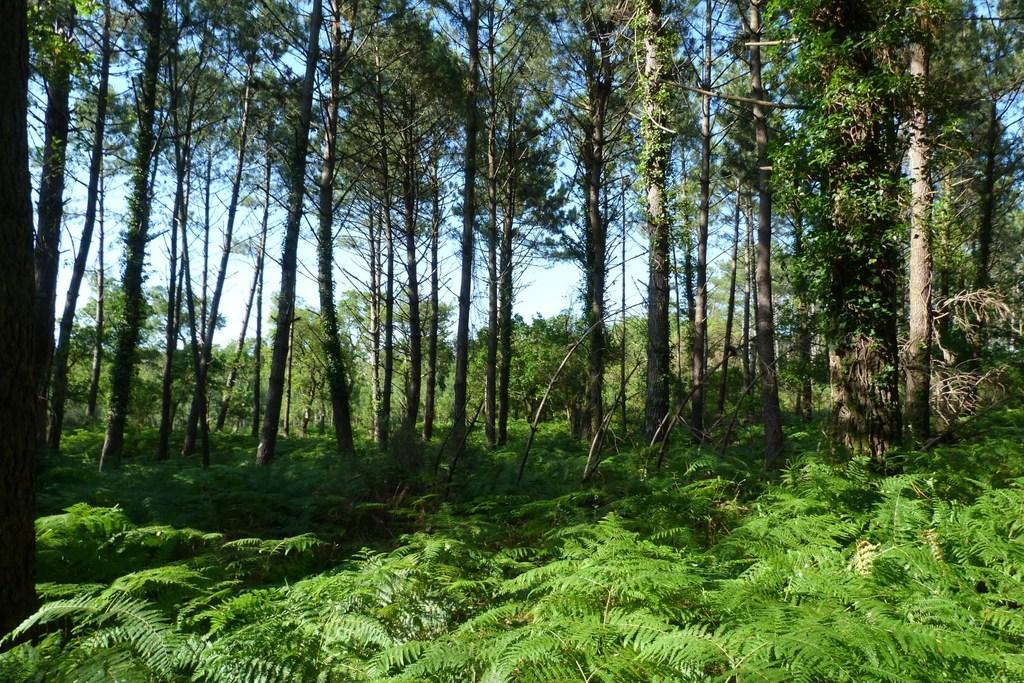What type of vegetation can be seen in the image? There are many trees and numerous plants in the image. Can you describe the density of the vegetation in the image? The image shows a dense concentration of trees and plants. How many ducks are swimming in the liquid in the image? There are no ducks or liquid present in the image; it features trees and plants. 